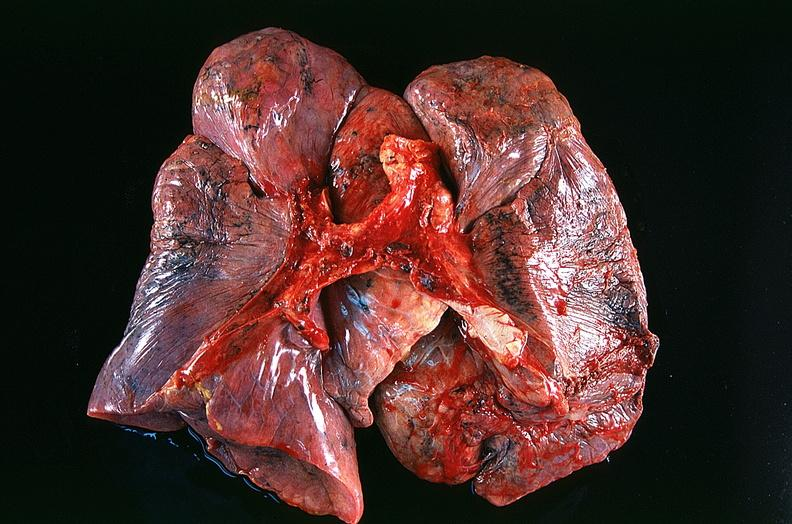s respiratory present?
Answer the question using a single word or phrase. Yes 